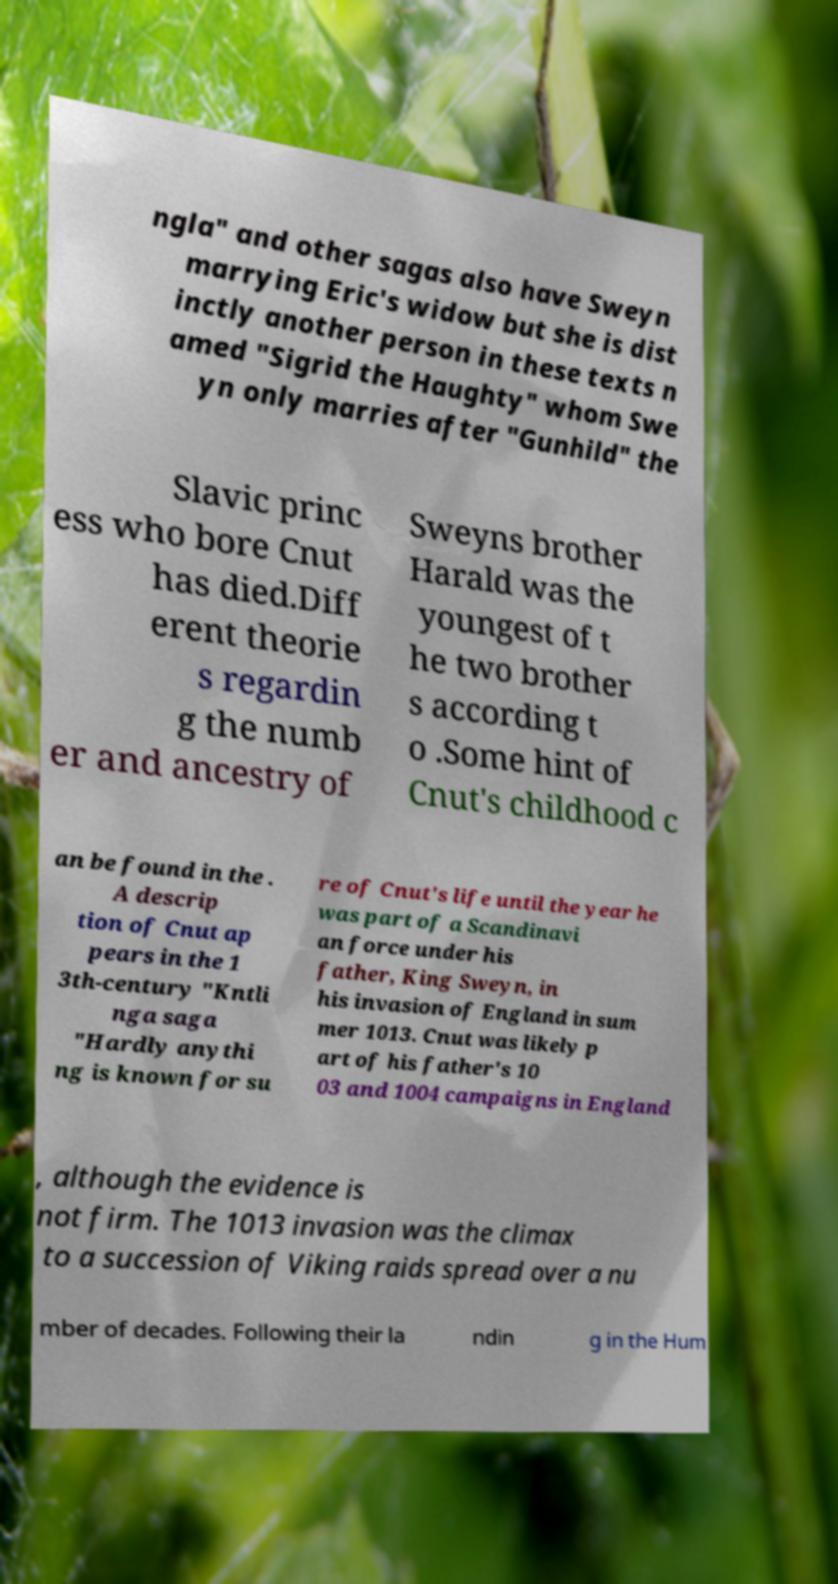Please identify and transcribe the text found in this image. ngla" and other sagas also have Sweyn marrying Eric's widow but she is dist inctly another person in these texts n amed "Sigrid the Haughty" whom Swe yn only marries after "Gunhild" the Slavic princ ess who bore Cnut has died.Diff erent theorie s regardin g the numb er and ancestry of Sweyns brother Harald was the youngest of t he two brother s according t o .Some hint of Cnut's childhood c an be found in the . A descrip tion of Cnut ap pears in the 1 3th-century "Kntli nga saga "Hardly anythi ng is known for su re of Cnut's life until the year he was part of a Scandinavi an force under his father, King Sweyn, in his invasion of England in sum mer 1013. Cnut was likely p art of his father's 10 03 and 1004 campaigns in England , although the evidence is not firm. The 1013 invasion was the climax to a succession of Viking raids spread over a nu mber of decades. Following their la ndin g in the Hum 